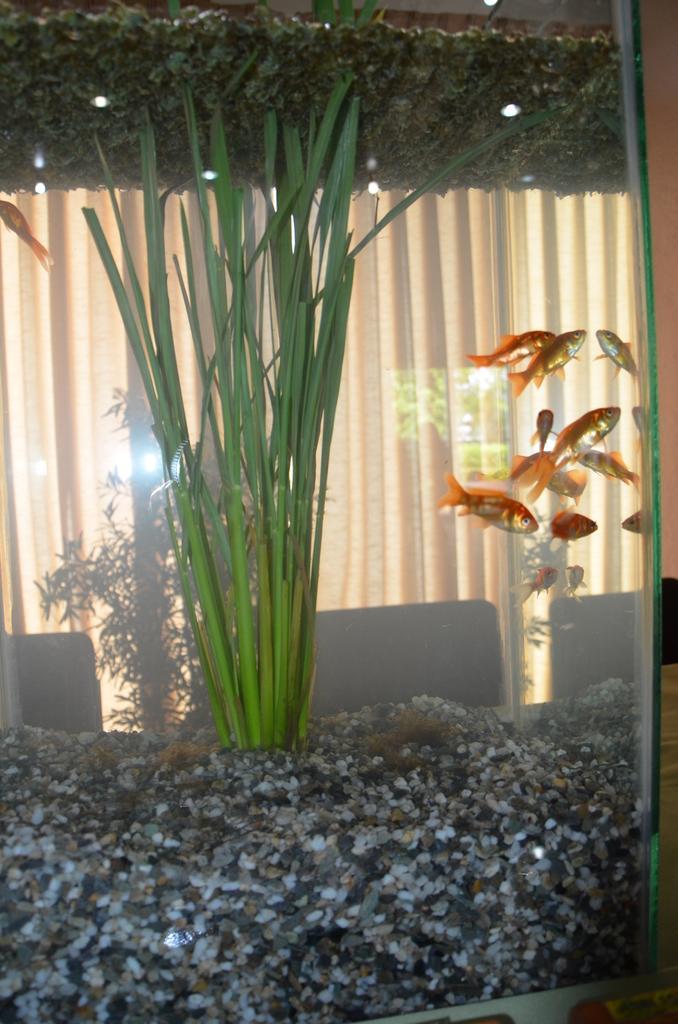In one or two sentences, can you explain what this image depicts? In this picture we can see an aquarium. In this aquarium, we can see a few fishes, plants and some stones. There is a glass object. Through this glass object, we can see a few chairs and a curtain in the background. 